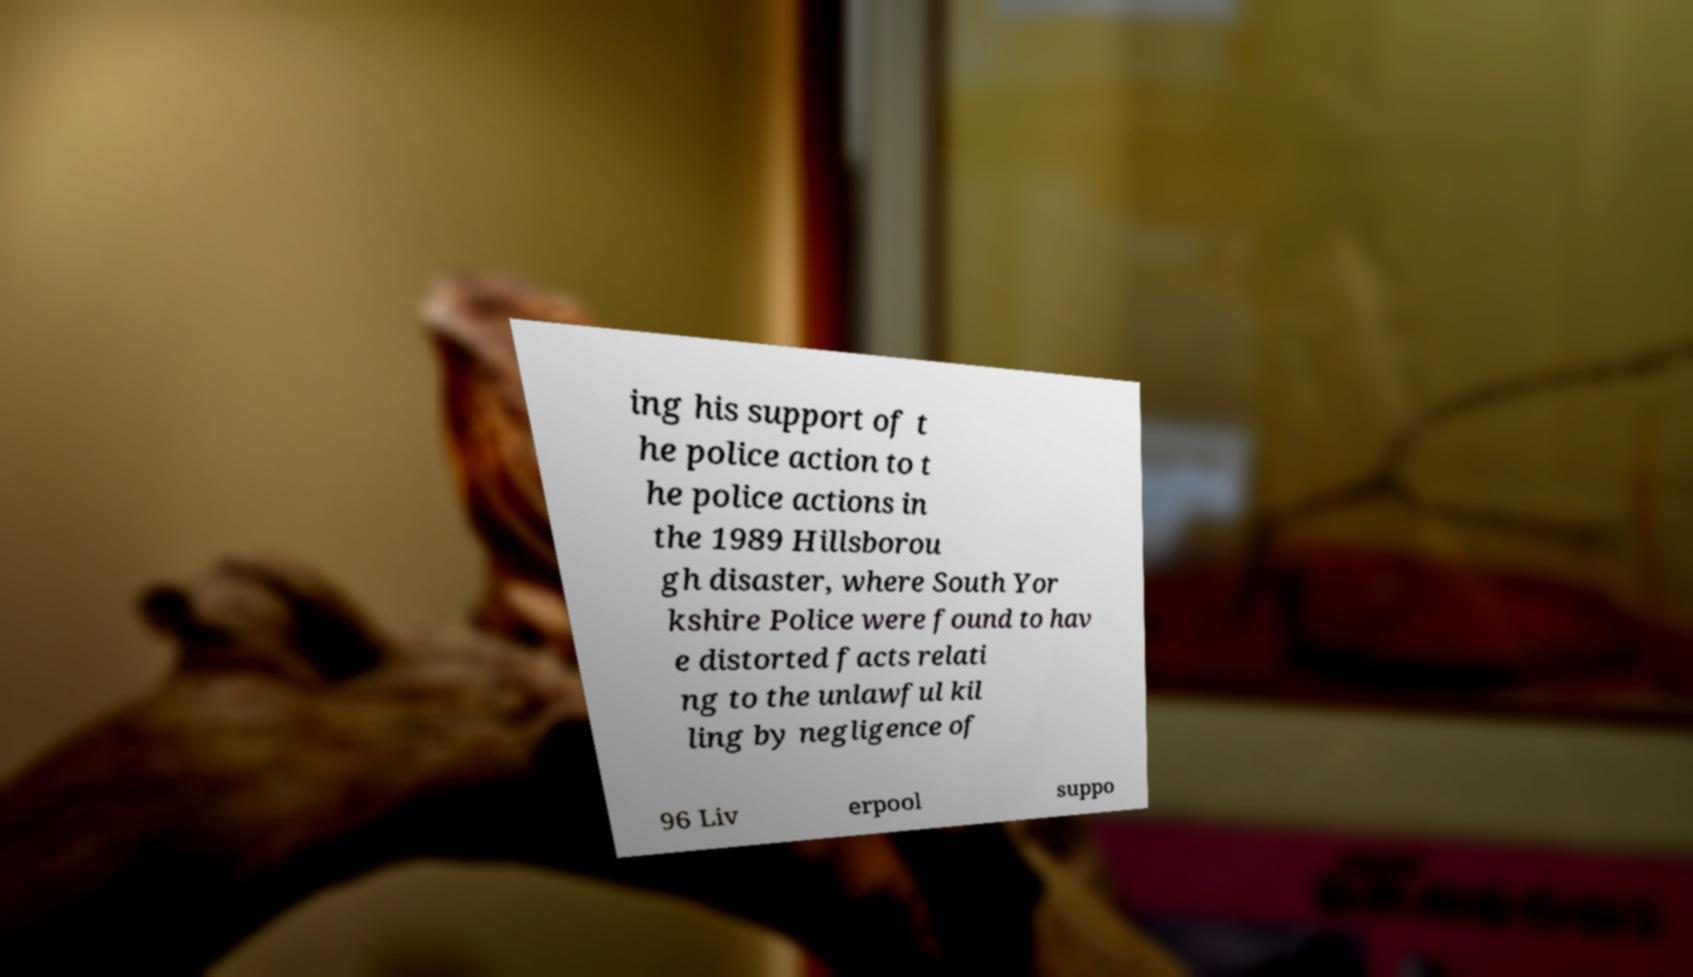What messages or text are displayed in this image? I need them in a readable, typed format. ing his support of t he police action to t he police actions in the 1989 Hillsborou gh disaster, where South Yor kshire Police were found to hav e distorted facts relati ng to the unlawful kil ling by negligence of 96 Liv erpool suppo 